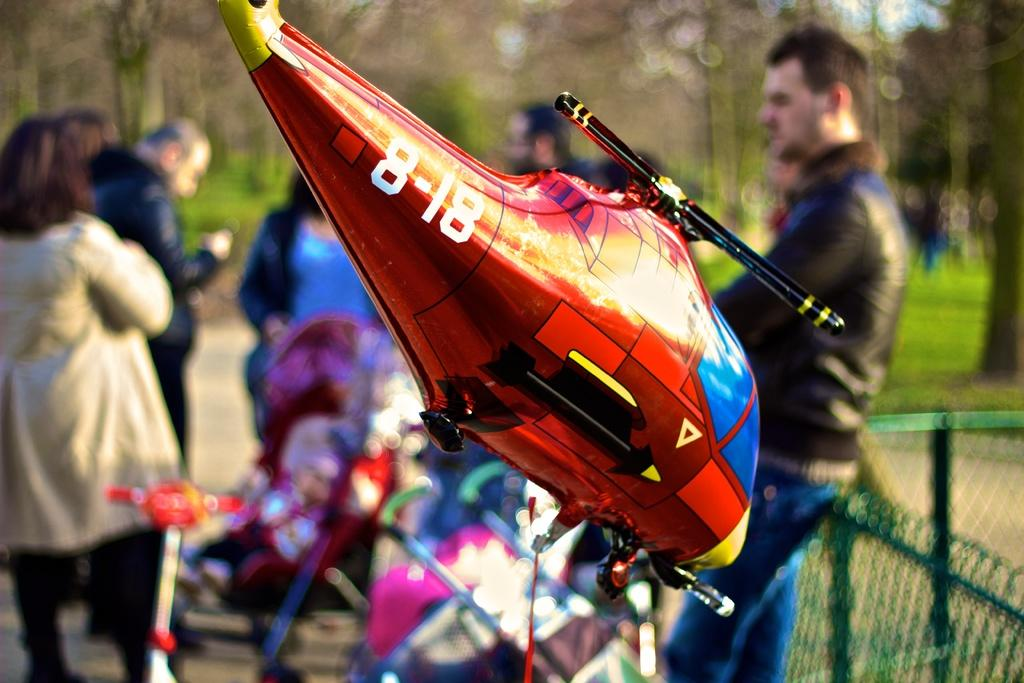Provide a one-sentence caption for the provided image. A toy balloon helicopter with the number 8-18 written on the tail. 